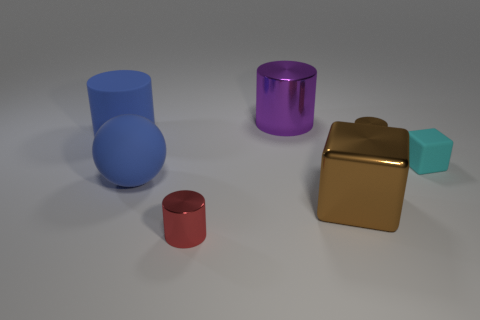Is the color of the small metal thing to the right of the big purple metallic object the same as the metal cube?
Ensure brevity in your answer.  Yes. Is the color of the large rubber ball the same as the cylinder that is on the left side of the red cylinder?
Keep it short and to the point. Yes. There is a sphere that is behind the large metallic object in front of the purple shiny cylinder; what is its material?
Provide a succinct answer. Rubber. Are there more small red cylinders in front of the matte ball than small green shiny balls?
Your answer should be compact. Yes. Is there a red metal cylinder?
Your answer should be very brief. Yes. What color is the cube on the left side of the tiny brown metal thing?
Keep it short and to the point. Brown. What is the material of the block that is the same size as the brown metallic cylinder?
Keep it short and to the point. Rubber. How many other objects are there of the same material as the big purple cylinder?
Provide a succinct answer. 3. What is the color of the rubber thing that is both to the left of the tiny cyan rubber thing and on the right side of the large rubber cylinder?
Your answer should be very brief. Blue. How many objects are either cylinders that are in front of the blue rubber cylinder or red cylinders?
Your response must be concise. 2. 